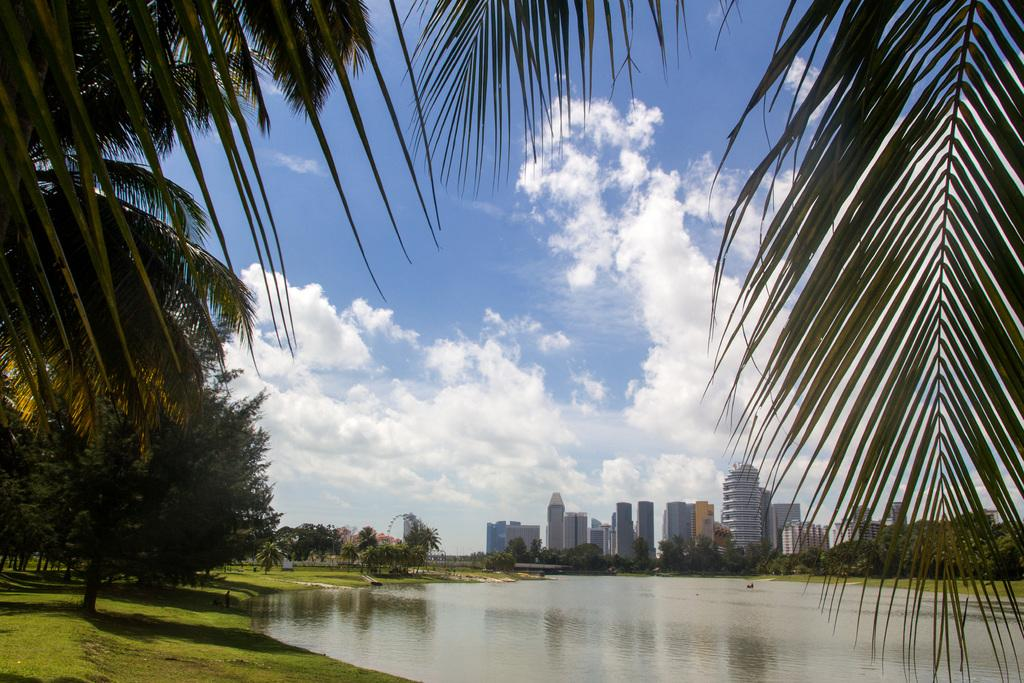What type of natural environment is depicted in the image? There are many trees in the image, indicating a natural environment. Are there any man-made structures visible in the image? Yes, there are buildings in the image. What is visible at the top of the image? The sky is visible at the top of the image. What can be seen in the sky? There are clouds in the sky. What type of body of water is present at the bottom of the image? There is a lake at the bottom of the image. What type of property is being sold in the image? There is no indication of any property being sold in the image. Can you tell me how many flights are visible in the image? There are no flights visible in the image; it depicts a natural environment with trees, buildings, and a lake. 